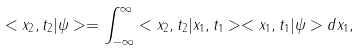Convert formula to latex. <formula><loc_0><loc_0><loc_500><loc_500>< x _ { 2 } , t _ { 2 } | \psi > = \int _ { - \infty } ^ { \infty } < x _ { 2 } , t _ { 2 } | x _ { 1 } , t _ { 1 } > < x _ { 1 } , t _ { 1 } | \psi > d x _ { 1 } ,</formula> 